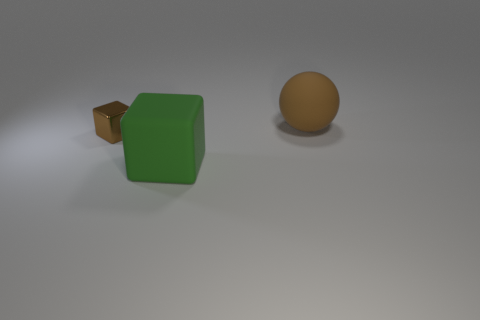Add 1 green matte things. How many objects exist? 4 Subtract all spheres. How many objects are left? 2 Subtract 1 brown balls. How many objects are left? 2 Subtract all small cubes. Subtract all rubber things. How many objects are left? 0 Add 3 tiny blocks. How many tiny blocks are left? 4 Add 2 metal objects. How many metal objects exist? 3 